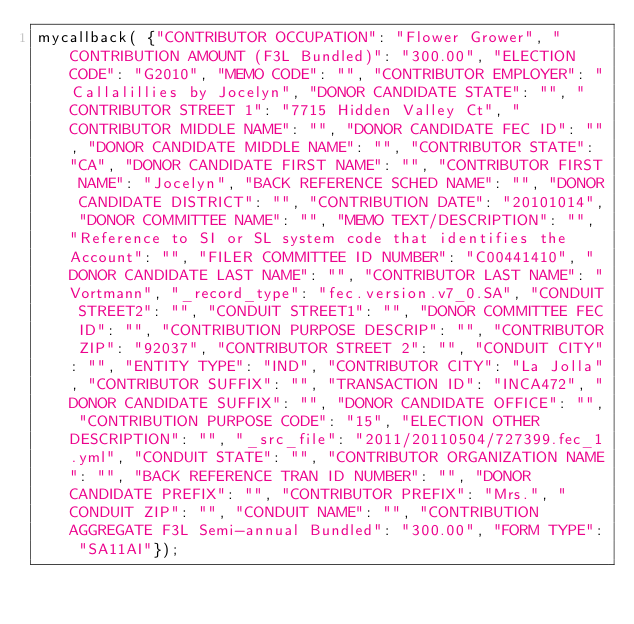<code> <loc_0><loc_0><loc_500><loc_500><_JavaScript_>mycallback( {"CONTRIBUTOR OCCUPATION": "Flower Grower", "CONTRIBUTION AMOUNT (F3L Bundled)": "300.00", "ELECTION CODE": "G2010", "MEMO CODE": "", "CONTRIBUTOR EMPLOYER": "Callalillies by Jocelyn", "DONOR CANDIDATE STATE": "", "CONTRIBUTOR STREET 1": "7715 Hidden Valley Ct", "CONTRIBUTOR MIDDLE NAME": "", "DONOR CANDIDATE FEC ID": "", "DONOR CANDIDATE MIDDLE NAME": "", "CONTRIBUTOR STATE": "CA", "DONOR CANDIDATE FIRST NAME": "", "CONTRIBUTOR FIRST NAME": "Jocelyn", "BACK REFERENCE SCHED NAME": "", "DONOR CANDIDATE DISTRICT": "", "CONTRIBUTION DATE": "20101014", "DONOR COMMITTEE NAME": "", "MEMO TEXT/DESCRIPTION": "", "Reference to SI or SL system code that identifies the Account": "", "FILER COMMITTEE ID NUMBER": "C00441410", "DONOR CANDIDATE LAST NAME": "", "CONTRIBUTOR LAST NAME": "Vortmann", "_record_type": "fec.version.v7_0.SA", "CONDUIT STREET2": "", "CONDUIT STREET1": "", "DONOR COMMITTEE FEC ID": "", "CONTRIBUTION PURPOSE DESCRIP": "", "CONTRIBUTOR ZIP": "92037", "CONTRIBUTOR STREET 2": "", "CONDUIT CITY": "", "ENTITY TYPE": "IND", "CONTRIBUTOR CITY": "La Jolla", "CONTRIBUTOR SUFFIX": "", "TRANSACTION ID": "INCA472", "DONOR CANDIDATE SUFFIX": "", "DONOR CANDIDATE OFFICE": "", "CONTRIBUTION PURPOSE CODE": "15", "ELECTION OTHER DESCRIPTION": "", "_src_file": "2011/20110504/727399.fec_1.yml", "CONDUIT STATE": "", "CONTRIBUTOR ORGANIZATION NAME": "", "BACK REFERENCE TRAN ID NUMBER": "", "DONOR CANDIDATE PREFIX": "", "CONTRIBUTOR PREFIX": "Mrs.", "CONDUIT ZIP": "", "CONDUIT NAME": "", "CONTRIBUTION AGGREGATE F3L Semi-annual Bundled": "300.00", "FORM TYPE": "SA11AI"});
</code> 